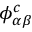Convert formula to latex. <formula><loc_0><loc_0><loc_500><loc_500>\phi _ { \alpha \beta } ^ { c }</formula> 